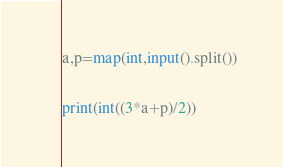Convert code to text. <code><loc_0><loc_0><loc_500><loc_500><_Python_>a,p=map(int,input().split())

print(int((3*a+p)/2))</code> 